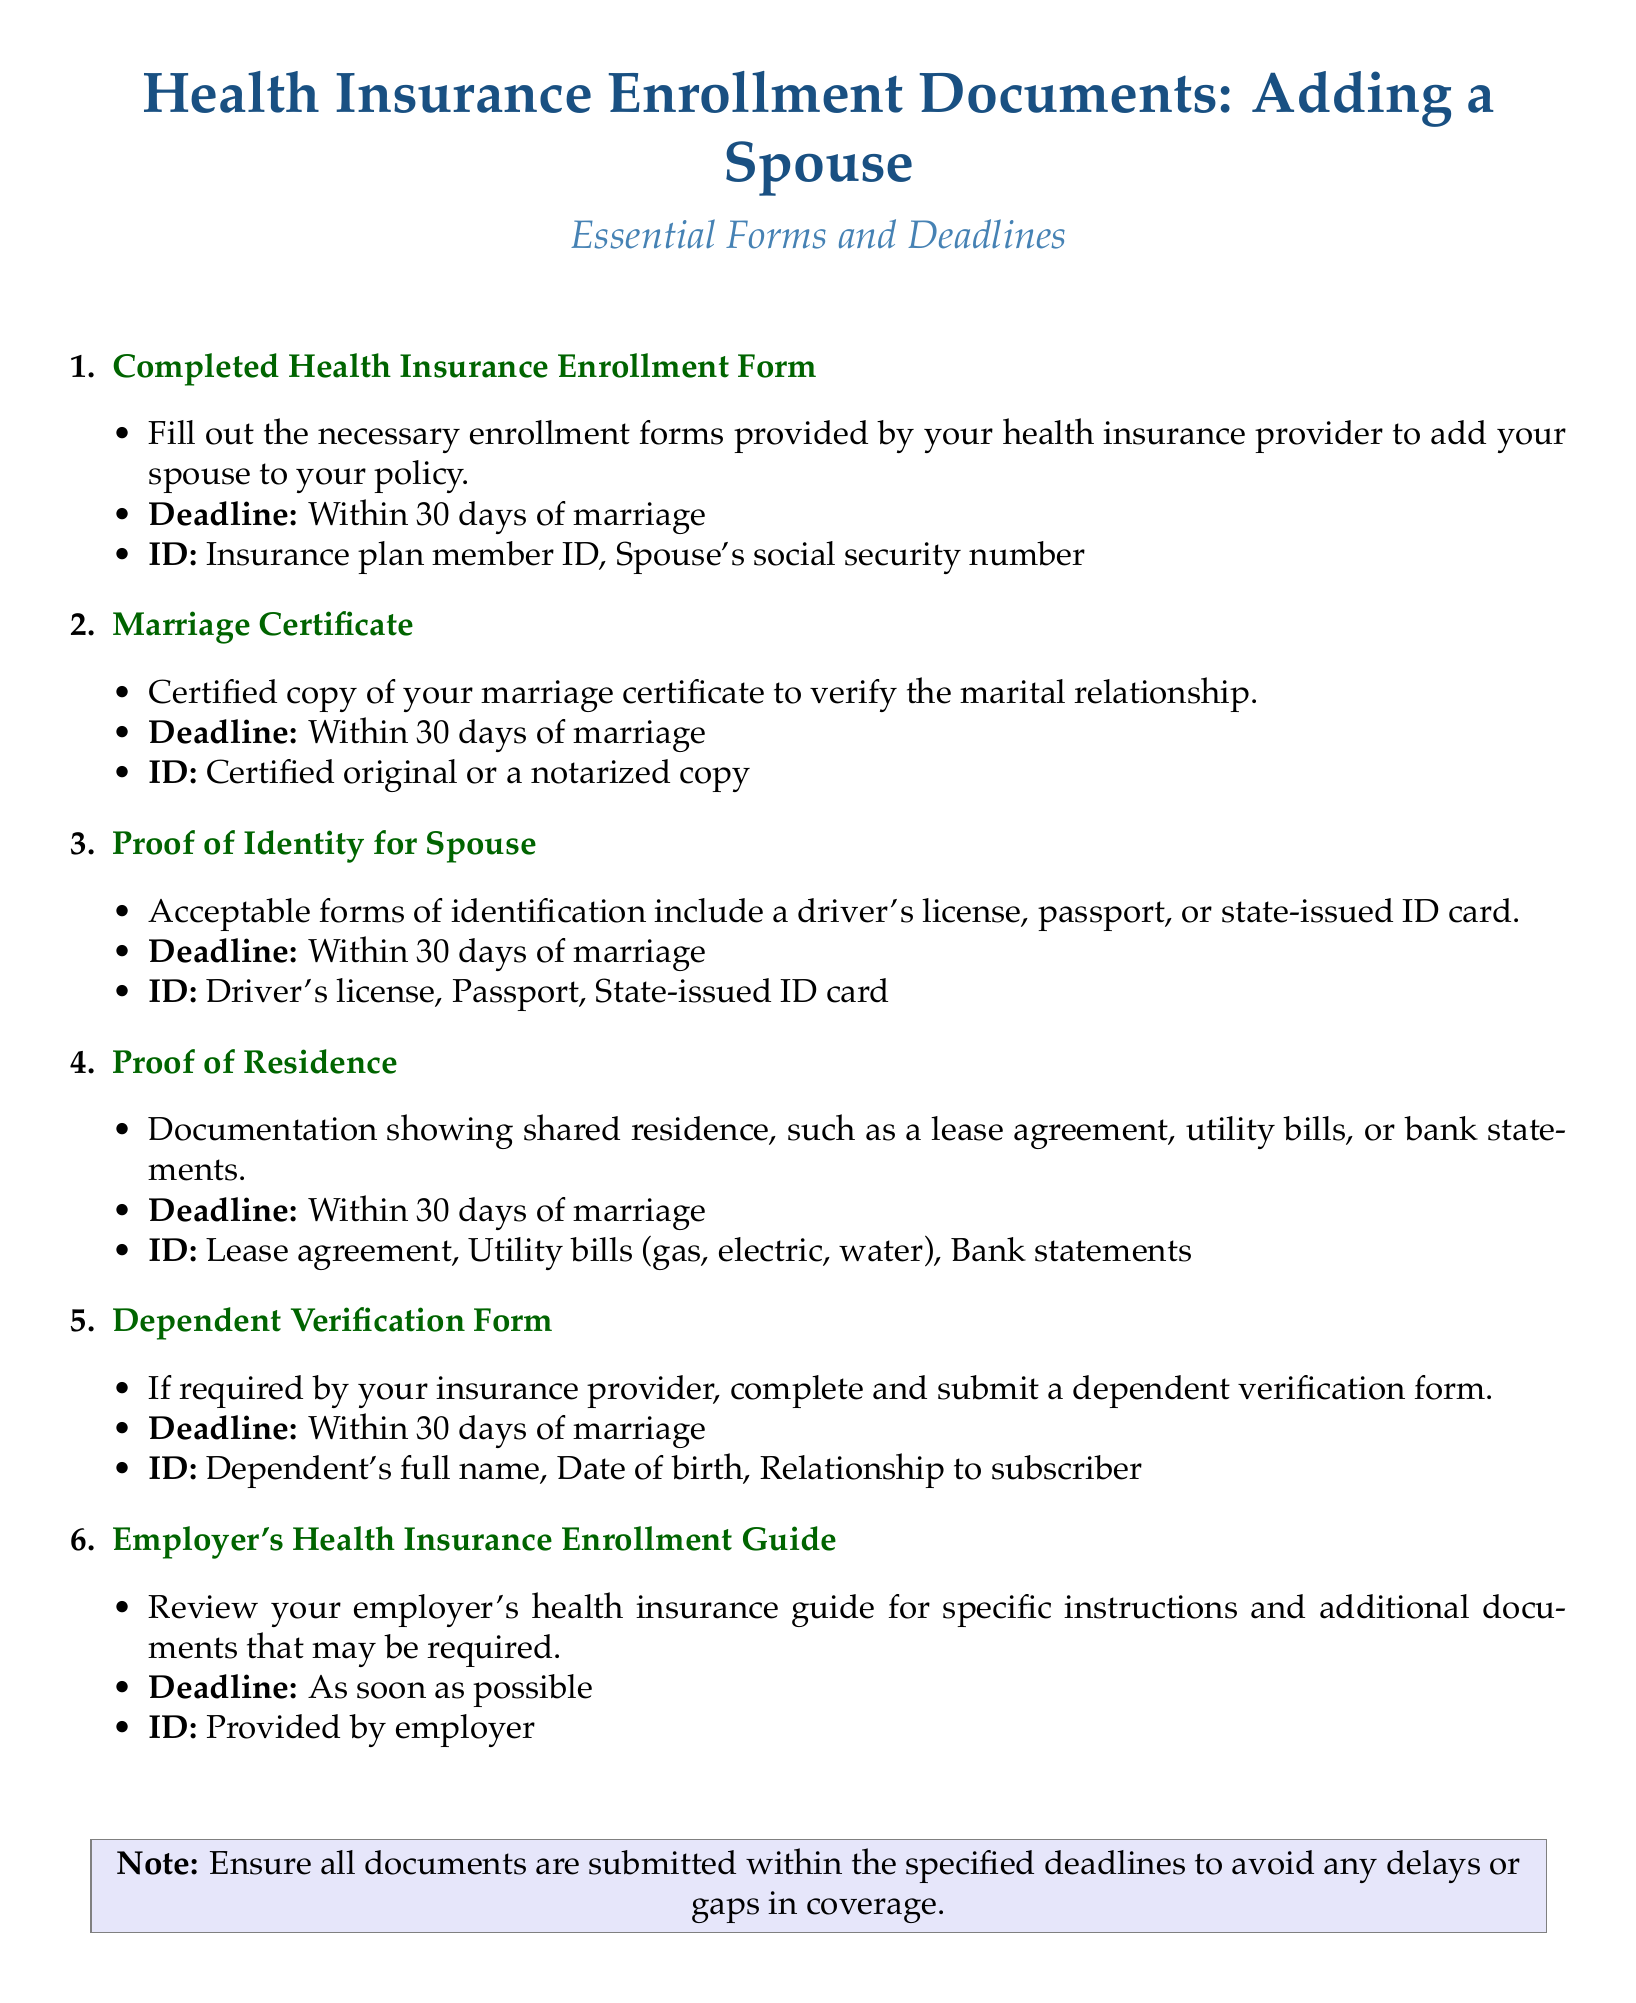What is the deadline for submitting the completed Health Insurance Enrollment Form? The deadline for submitting the completed form is mentioned as "Within 30 days of marriage."
Answer: Within 30 days of marriage What document is required to verify the marital relationship? The document necessary to verify the marital relationship is the "Marriage Certificate."
Answer: Marriage Certificate Which IDs are acceptable for Proof of Identity for the spouse? The document lists acceptable forms of identification which are "Driver's license, Passport, State-issued ID card."
Answer: Driver's license, Passport, State-issued ID card What is the purpose of the Dependent Verification Form? The purpose of the Dependent Verification Form is to "complete and submit a dependent verification form" if required by the insurance provider.
Answer: If required by your insurance provider How long do I have to submit all required documents after getting married? The document specifies that all required documents must be submitted within "30 days of marriage."
Answer: 30 days of marriage What should the Proof of Residence documentation show? The documentation for Proof of Residence needs to show "shared residence" such as a lease agreement or utility bills.
Answer: Shared residence Who provides the Employer's Health Insurance Enrollment Guide? The section indicates that the "Employer" provides the Health Insurance Enrollment Guide for specifics.
Answer: Employer What is noted at the bottom of the document regarding deadlines? The note states, "Ensure all documents are submitted within the specified deadlines."
Answer: Ensure all documents are submitted within the specified deadlines 